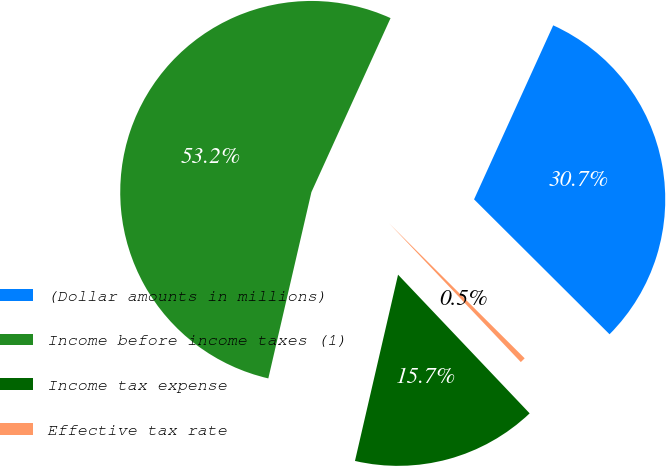Convert chart. <chart><loc_0><loc_0><loc_500><loc_500><pie_chart><fcel>(Dollar amounts in millions)<fcel>Income before income taxes (1)<fcel>Income tax expense<fcel>Effective tax rate<nl><fcel>30.67%<fcel>53.17%<fcel>15.7%<fcel>0.45%<nl></chart> 